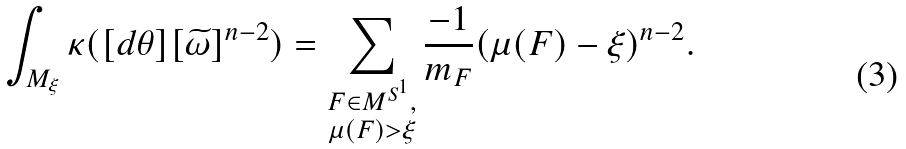Convert formula to latex. <formula><loc_0><loc_0><loc_500><loc_500>\int _ { M _ { \xi } } \kappa ( [ d \theta ] [ \widetilde { \omega } ] ^ { n - 2 } ) = \sum _ { \substack { F \in M ^ { S ^ { 1 } } , \\ \mu ( F ) > \xi } } \frac { - 1 } { m _ { F } } ( \mu ( F ) - \xi ) ^ { n - 2 } .</formula> 